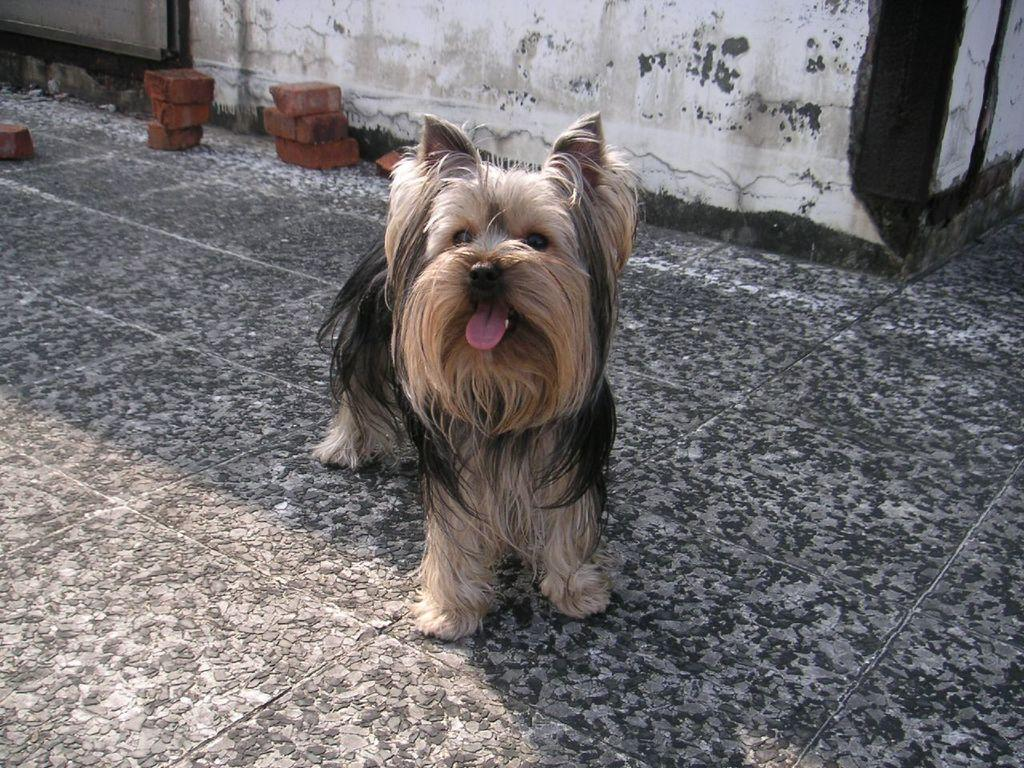What type of animal is in the image? There is a dog in the image. Can you describe the color of the dog? The dog is brown and black in color. What can be seen in the background of the image? There are bricks visible in the background of the image. How would you describe the color of the wall in the background? The wall in the background is white and black in color. What type of mask is the dog wearing in the image? There is no mask present in the image; the dog is not wearing any mask. 